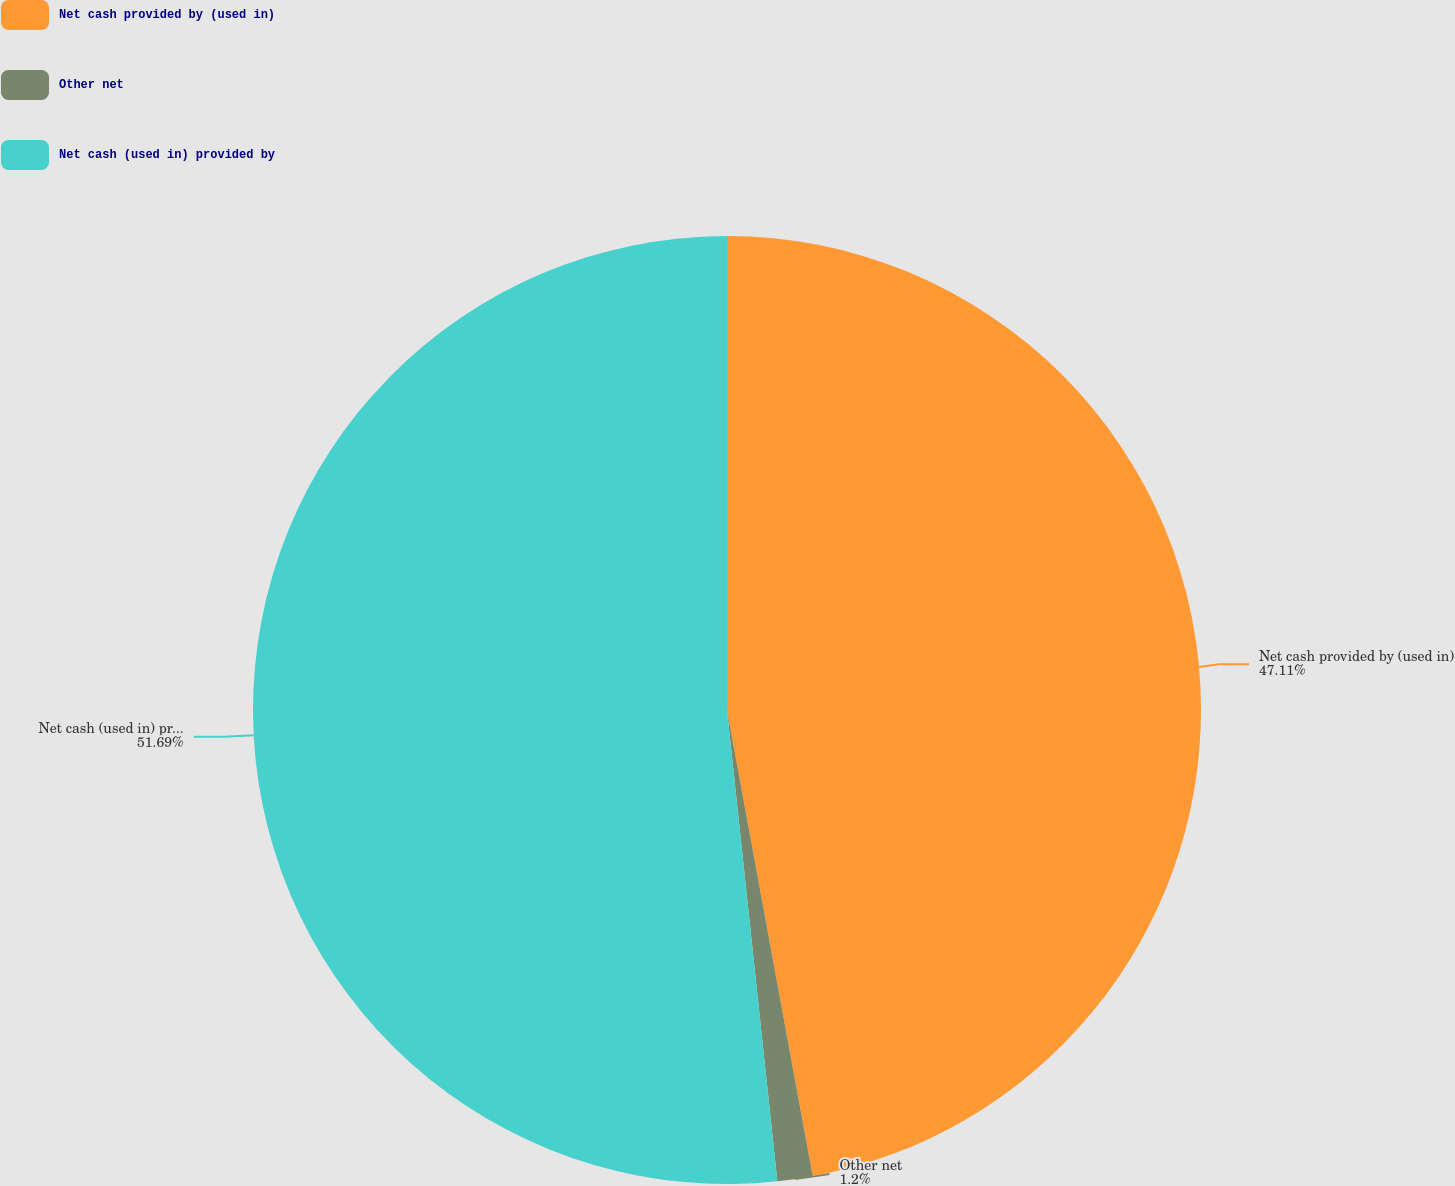Convert chart to OTSL. <chart><loc_0><loc_0><loc_500><loc_500><pie_chart><fcel>Net cash provided by (used in)<fcel>Other net<fcel>Net cash (used in) provided by<nl><fcel>47.11%<fcel>1.2%<fcel>51.7%<nl></chart> 